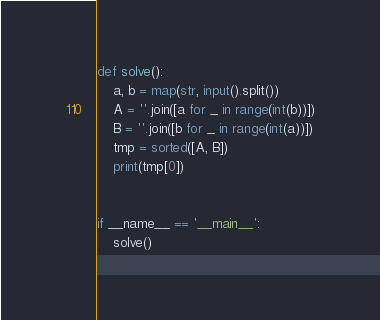Convert code to text. <code><loc_0><loc_0><loc_500><loc_500><_Python_>def solve():
    a, b = map(str, input().split())
    A = ''.join([a for _ in range(int(b))])
    B = ''.join([b for _ in range(int(a))])
    tmp = sorted([A, B])
    print(tmp[0])


if __name__ == '__main__':
    solve()
</code> 